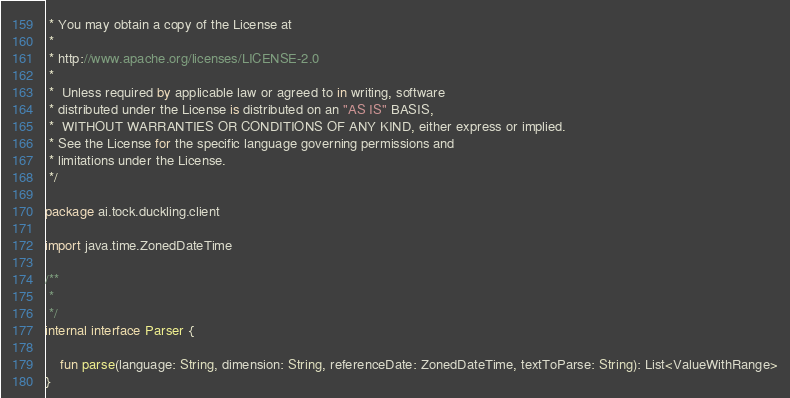Convert code to text. <code><loc_0><loc_0><loc_500><loc_500><_Kotlin_> * You may obtain a copy of the License at
 *
 * http://www.apache.org/licenses/LICENSE-2.0
 *
 *  Unless required by applicable law or agreed to in writing, software
 * distributed under the License is distributed on an "AS IS" BASIS,
 *  WITHOUT WARRANTIES OR CONDITIONS OF ANY KIND, either express or implied.
 * See the License for the specific language governing permissions and
 * limitations under the License.
 */

package ai.tock.duckling.client

import java.time.ZonedDateTime

/**
 *
 */
internal interface Parser {

    fun parse(language: String, dimension: String, referenceDate: ZonedDateTime, textToParse: String): List<ValueWithRange>
}</code> 